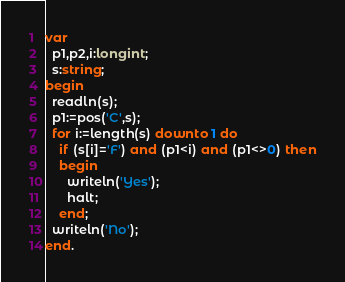<code> <loc_0><loc_0><loc_500><loc_500><_Pascal_>var
  p1,p2,i:longint;
  s:string;
begin
  readln(s);
  p1:=pos('C',s);
  for i:=length(s) downto 1 do
    if (s[i]='F') and (p1<i) and (p1<>0) then
    begin
      writeln('Yes');
      halt;
    end;
  writeln('No');
end.</code> 